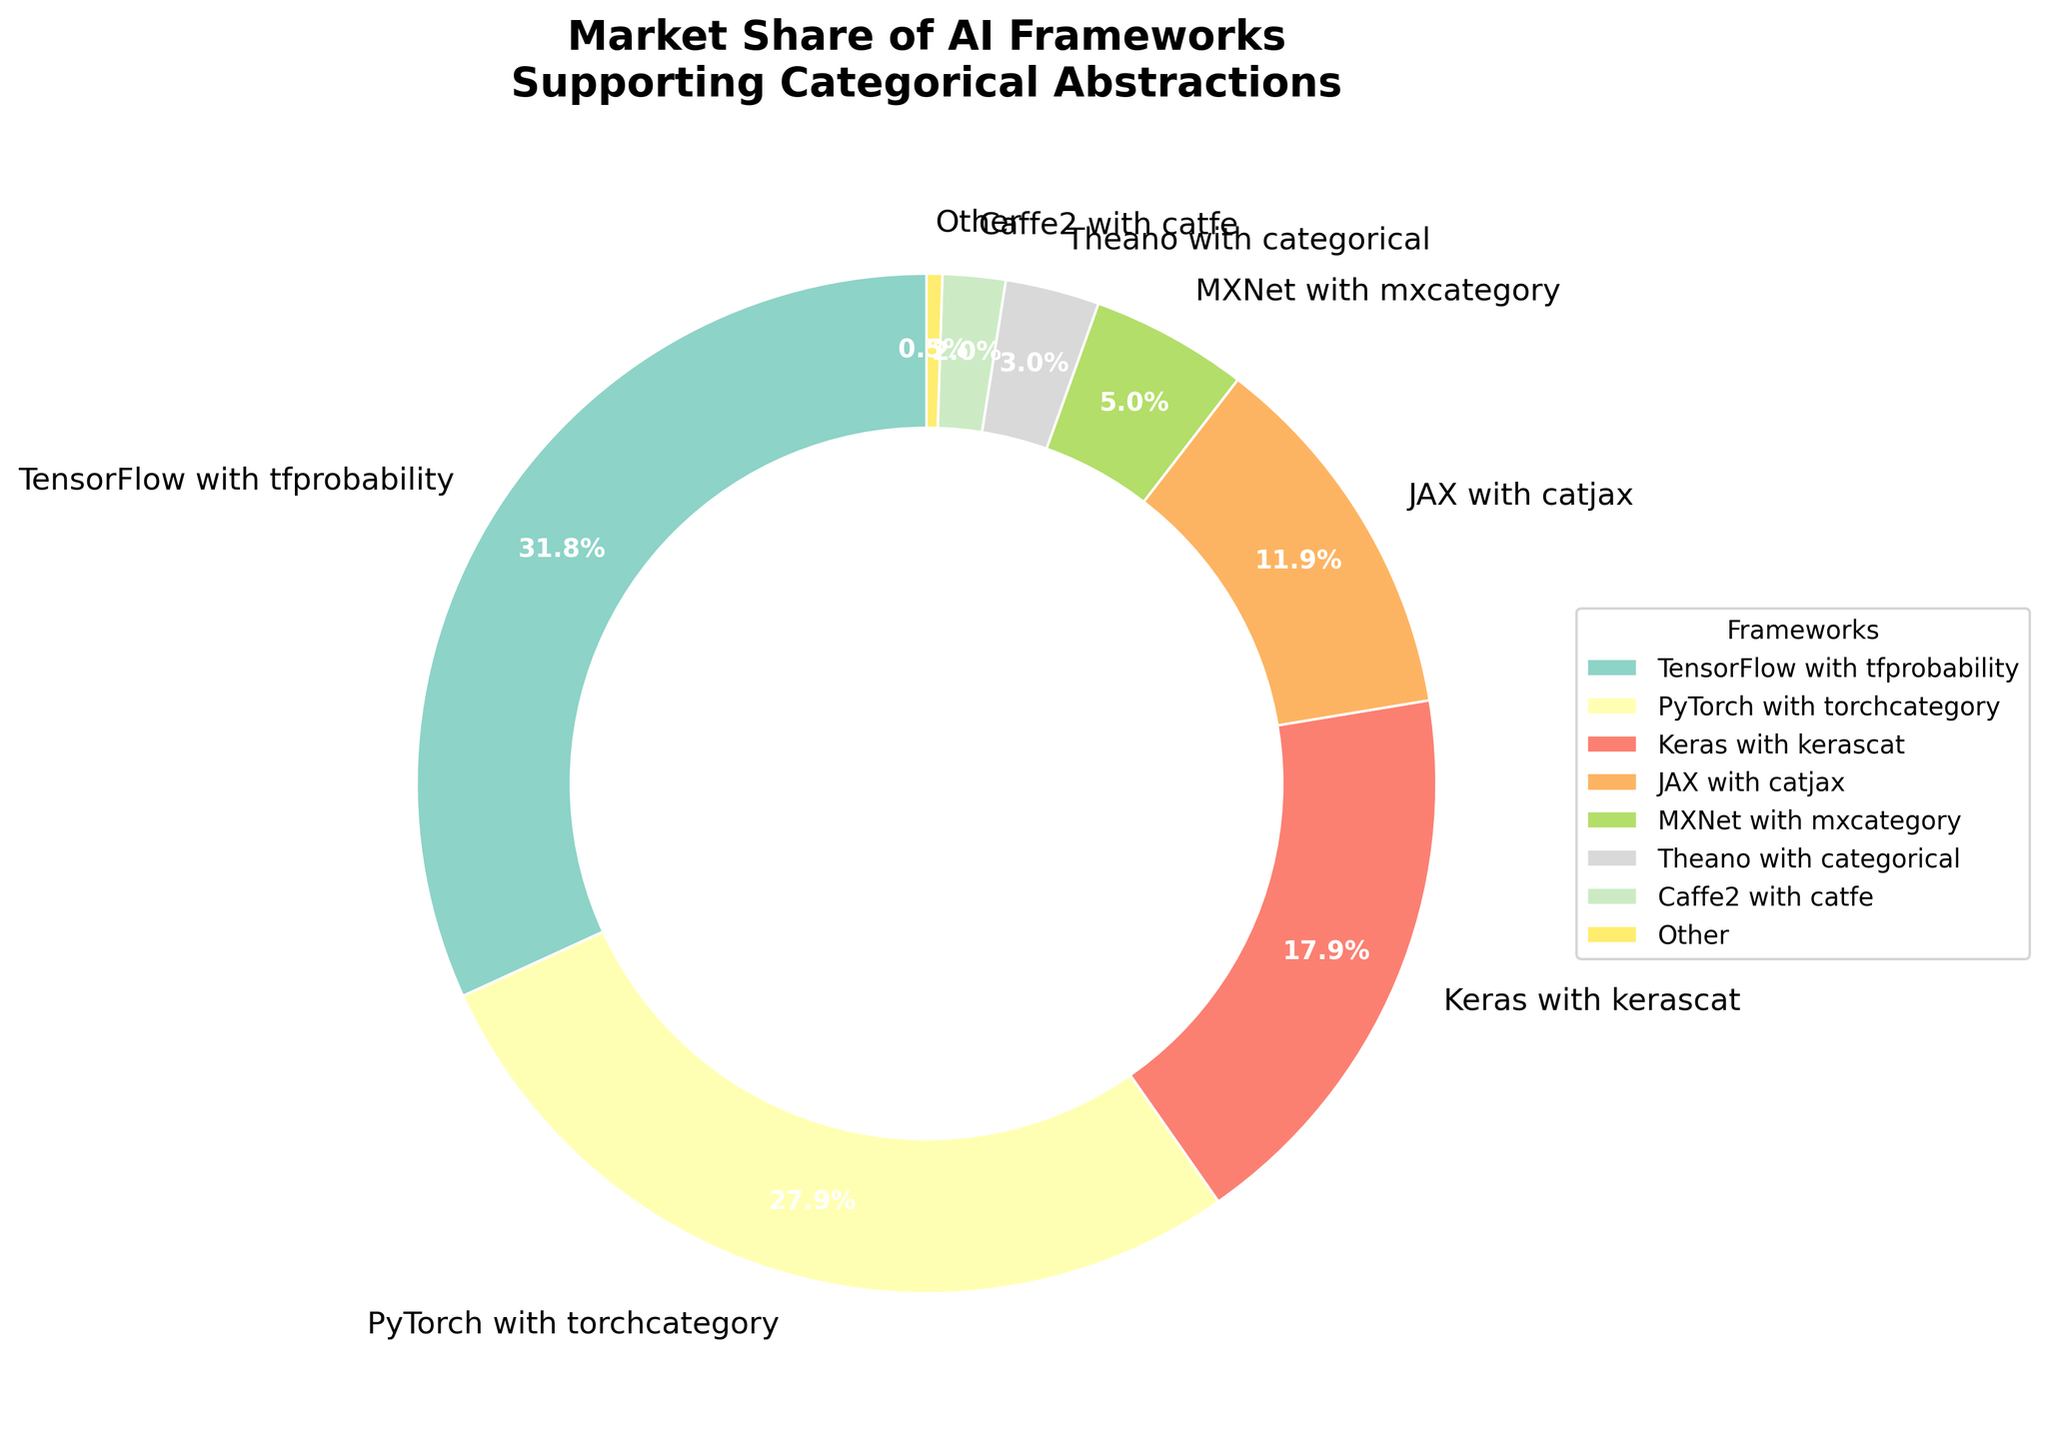What is the market share of TensorFlow with tfprobability? The market share of TensorFlow with tfprobability is explicitly labeled on the pie chart.
Answer: 32% Which AI framework has the smallest market share? By examining the pie chart and the corresponding labels, Caffe2 with catfe is identified as the segment with the smallest percentage.
Answer: Caffe2 with catfe How much larger is the market share of PyTorch with torchcategory compared to JAX with catjax? The market shares of PyTorch with torchcategory and JAX with catjax are provided. Subtracting the share of JAX with catjax from PyTorch with torchcategory gives the difference. 28% - 12% = 16%.
Answer: 16% Combine the market shares of the frameworks with the three smallest shares. What's their total? The three smallest shares belong to Theano with categorical, Caffe2 with catfe, and Other. Summing these shares: 3% + 2% + 0.5% = 5.5%.
Answer: 5.5% What is the combined market share of TensorFlow with tfprobability and Keras with kerascat? Adding the market shares of TensorFlow with tfprobability and Keras with kerascat gives: 32% + 18% = 50%.
Answer: 50% Which AI framework supporting categorical abstractions has the second-largest market share, and what is its percentage? By examining the pie slices, the second-largest market share is PyTorch with torchcategory, labeled as 28%.
Answer: PyTorch with torchcategory, 28% What is the percentage gap between the framework with the largest market share and the framework with the smallest market share? Subtracting the smallest market share (Caffe2 with catfe, 2%) from the largest one (TensorFlow with tfprobability, 32%) results in the gap: 32% - 2% = 30%.
Answer: 30% What color represents MXNet with mxcategory in the pie chart? The color assigned to MXNet with mxcategory can be identified by looking at the corresponding segment in the pie chart.
Answer: Varies (based on the colormap but typically pastel like color, as defined by the Set3 colormap) 